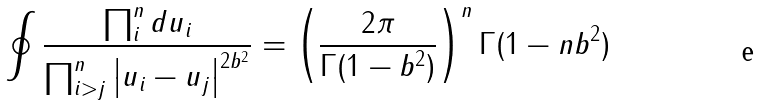Convert formula to latex. <formula><loc_0><loc_0><loc_500><loc_500>\oint \frac { \prod _ { i } ^ { n } d u _ { i } } { \prod _ { i > j } ^ { n } \left | u _ { i } - u _ { j } \right | ^ { 2 b ^ { 2 } } } = \left ( \frac { 2 \pi } { \Gamma ( 1 - b ^ { 2 } ) } \right ) ^ { n } \Gamma ( 1 - n b ^ { 2 } )</formula> 